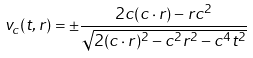Convert formula to latex. <formula><loc_0><loc_0><loc_500><loc_500>v _ { c } ( t , r ) = \pm \frac { 2 c ( c \cdot r ) - r c ^ { 2 } } { \sqrt { 2 ( c \cdot r ) ^ { 2 } - c ^ { 2 } r ^ { 2 } - c ^ { 4 } t ^ { 2 } } }</formula> 